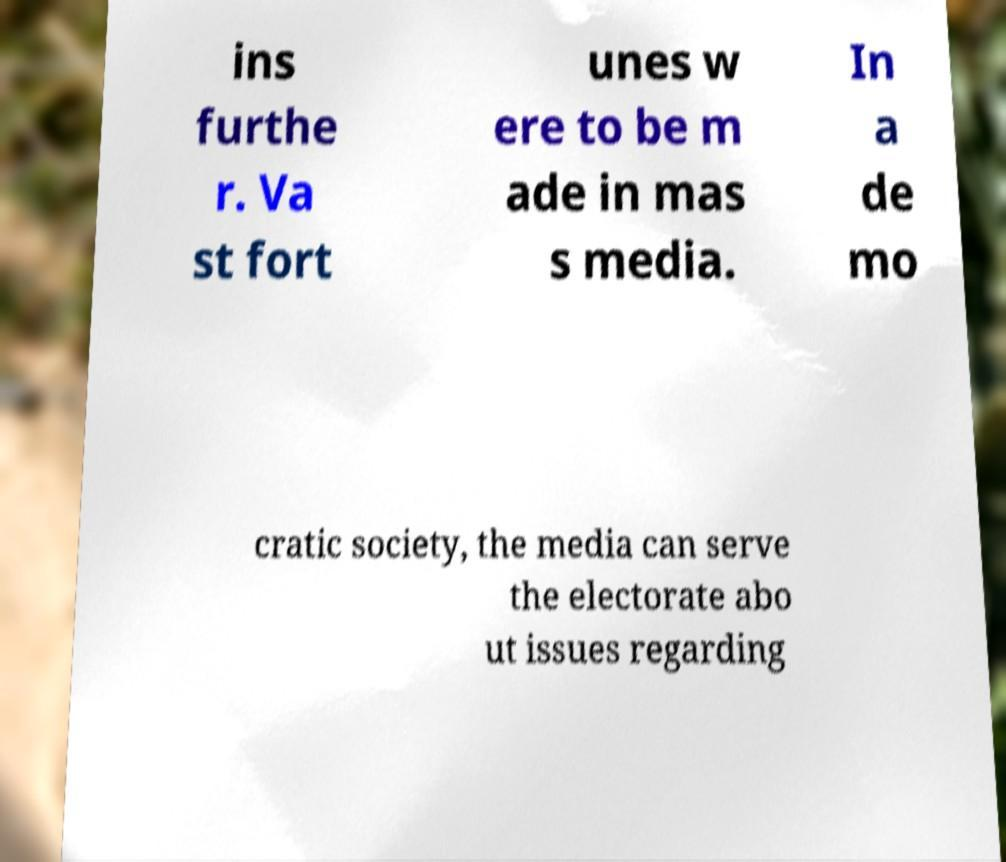There's text embedded in this image that I need extracted. Can you transcribe it verbatim? ins furthe r. Va st fort unes w ere to be m ade in mas s media. In a de mo cratic society, the media can serve the electorate abo ut issues regarding 